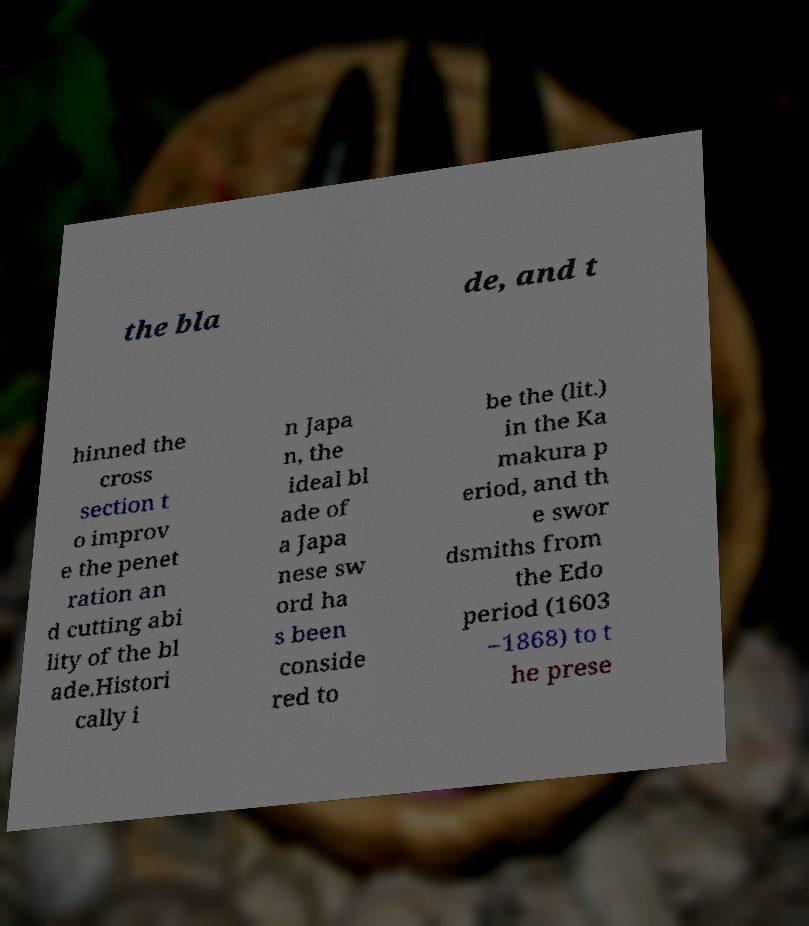I need the written content from this picture converted into text. Can you do that? the bla de, and t hinned the cross section t o improv e the penet ration an d cutting abi lity of the bl ade.Histori cally i n Japa n, the ideal bl ade of a Japa nese sw ord ha s been conside red to be the (lit.) in the Ka makura p eriod, and th e swor dsmiths from the Edo period (1603 –1868) to t he prese 